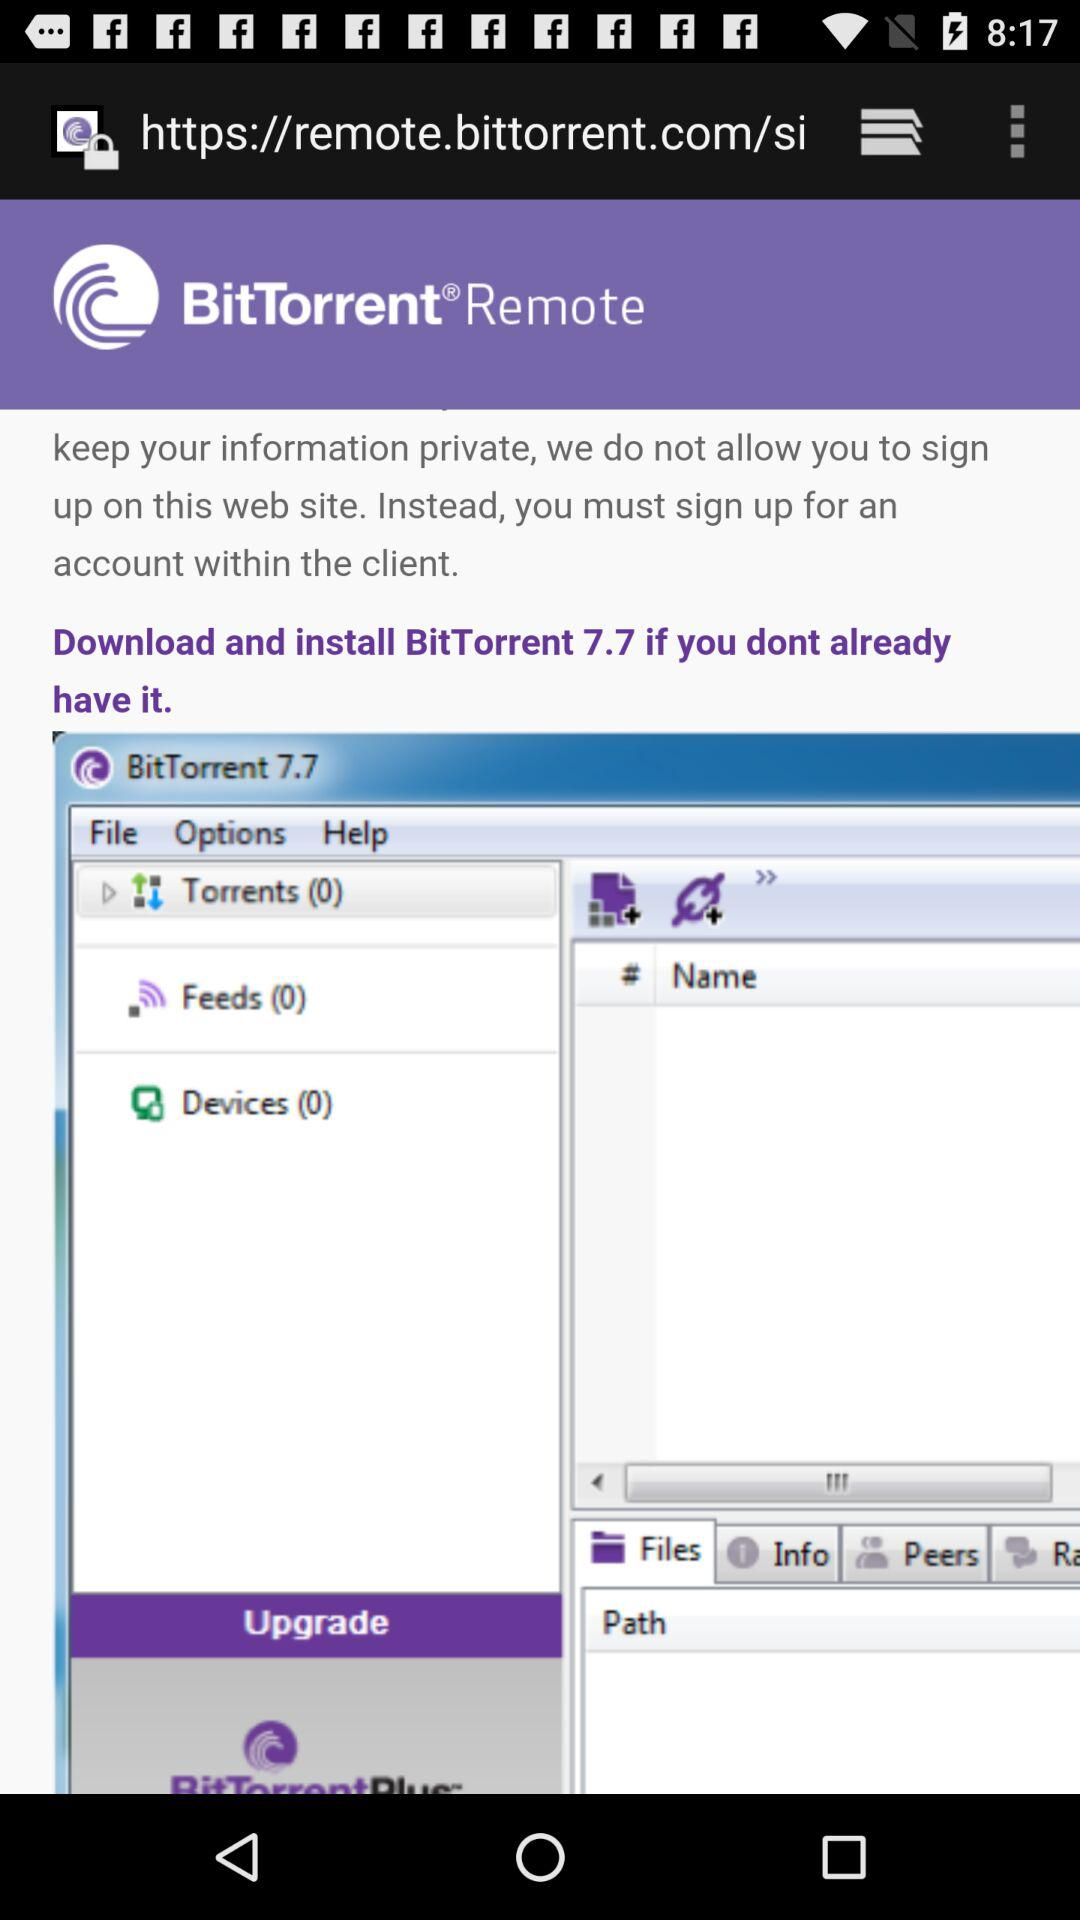What is the application name? The application name is "BitTorrent". 